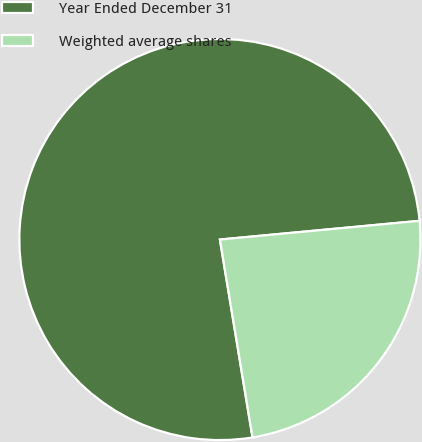<chart> <loc_0><loc_0><loc_500><loc_500><pie_chart><fcel>Year Ended December 31<fcel>Weighted average shares<nl><fcel>76.11%<fcel>23.89%<nl></chart> 